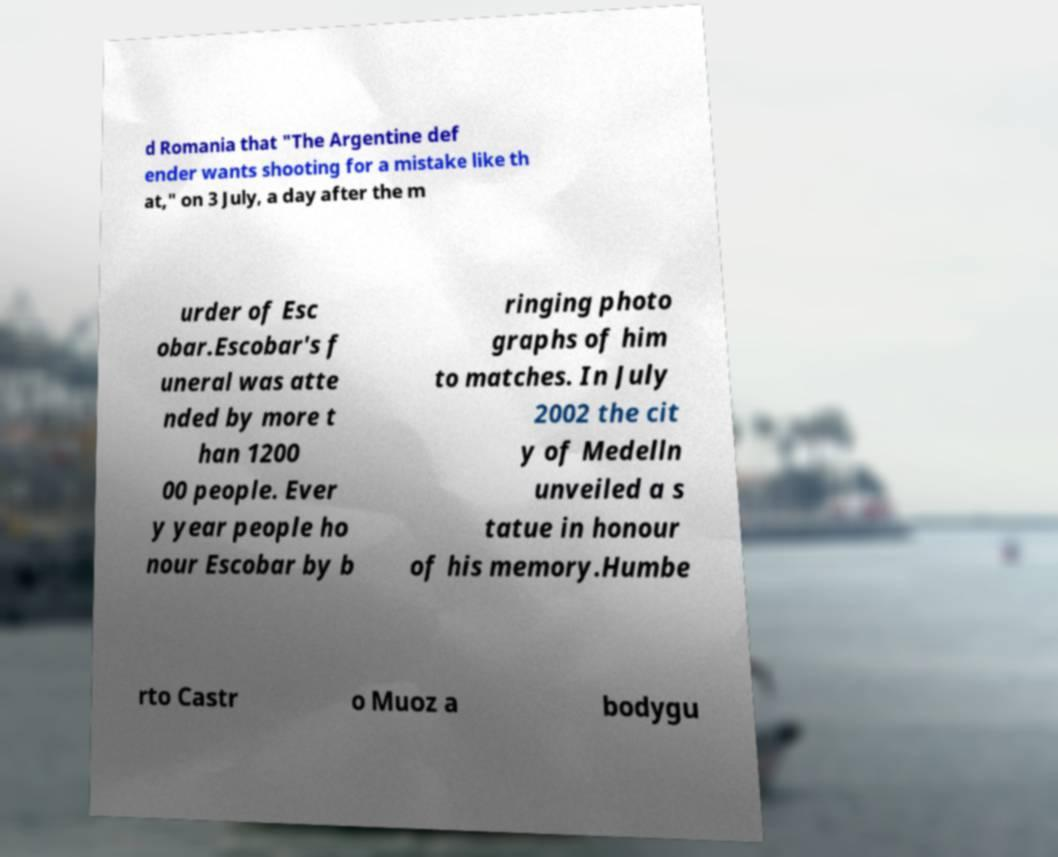Could you assist in decoding the text presented in this image and type it out clearly? d Romania that "The Argentine def ender wants shooting for a mistake like th at," on 3 July, a day after the m urder of Esc obar.Escobar's f uneral was atte nded by more t han 1200 00 people. Ever y year people ho nour Escobar by b ringing photo graphs of him to matches. In July 2002 the cit y of Medelln unveiled a s tatue in honour of his memory.Humbe rto Castr o Muoz a bodygu 